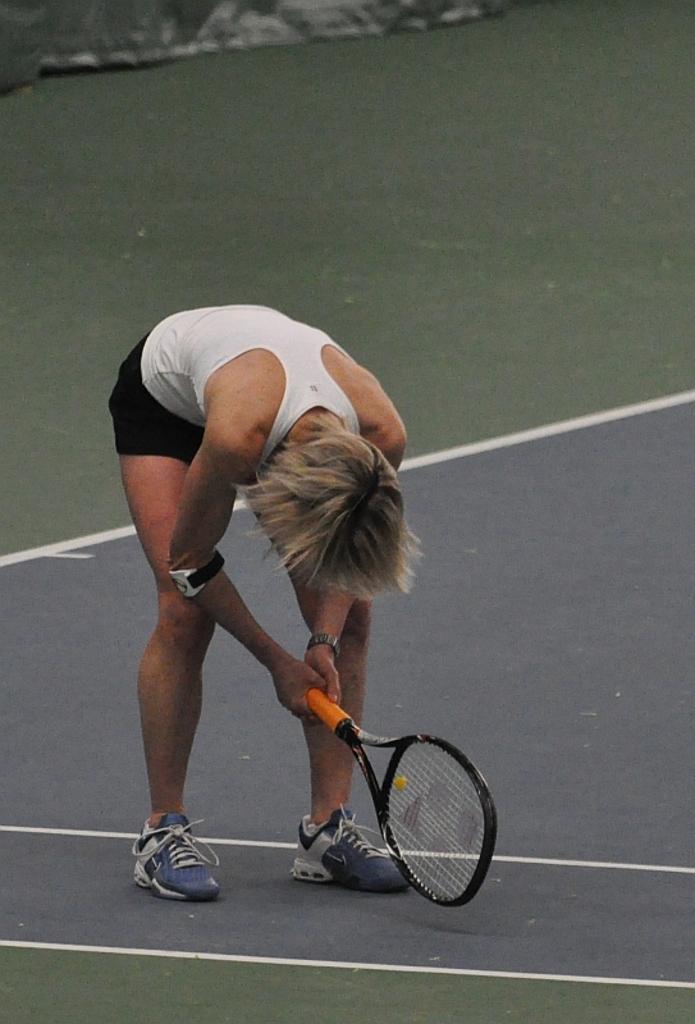How would you summarize this image in a sentence or two? In this image we can see one person in bending position and holding a tennis racket on the ground. There is one object on the ground at the top of the image. 